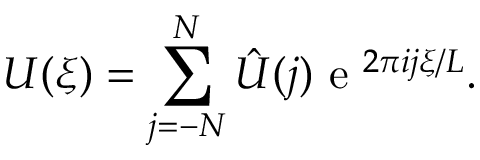Convert formula to latex. <formula><loc_0><loc_0><loc_500><loc_500>U ( \xi ) = \sum _ { j = - N } ^ { N } \hat { U } ( j ) e ^ { 2 \pi i j \xi / L } .</formula> 